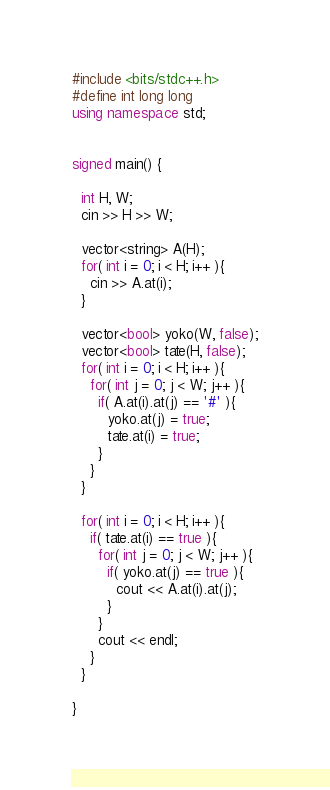Convert code to text. <code><loc_0><loc_0><loc_500><loc_500><_C++_>#include <bits/stdc++.h>
#define int long long
using namespace std;


signed main() {
  
  int H, W;
  cin >> H >> W;
  
  vector<string> A(H);
  for( int i = 0; i < H; i++ ){
    cin >> A.at(i);
  }
  
  vector<bool> yoko(W, false);
  vector<bool> tate(H, false);
  for( int i = 0; i < H; i++ ){
    for( int j = 0; j < W; j++ ){
      if( A.at(i).at(j) == '#' ){
        yoko.at(j) = true;
        tate.at(i) = true;
      }
    }
  }
  
  for( int i = 0; i < H; i++ ){
    if( tate.at(i) == true ){
      for( int j = 0; j < W; j++ ){
        if( yoko.at(j) == true ){
          cout << A.at(i).at(j);
        }
      }
      cout << endl;
    }
  }
  
}

</code> 